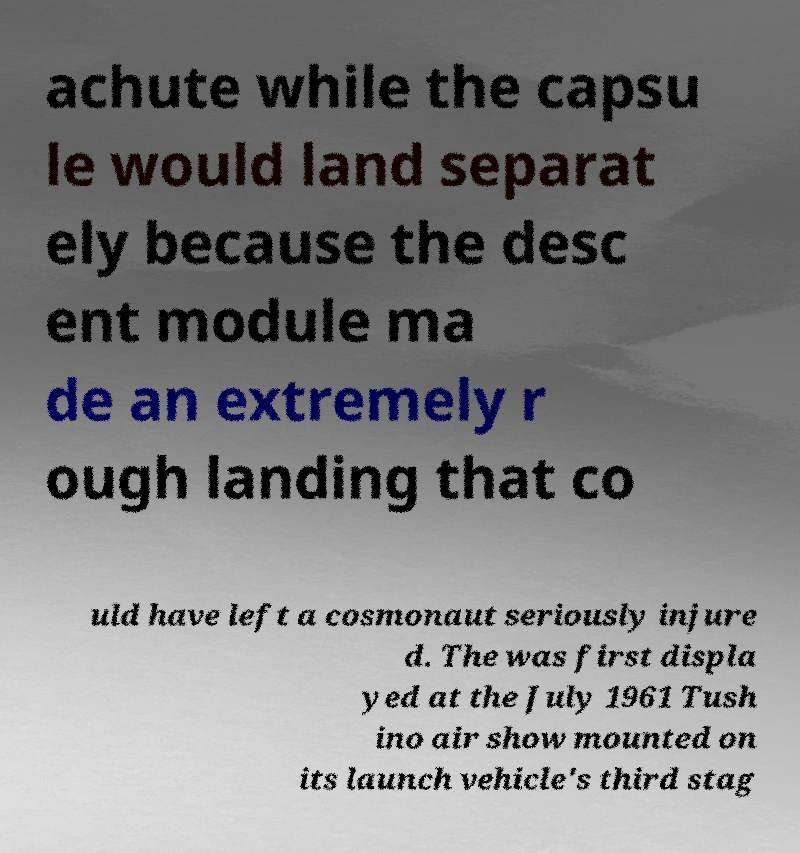I need the written content from this picture converted into text. Can you do that? achute while the capsu le would land separat ely because the desc ent module ma de an extremely r ough landing that co uld have left a cosmonaut seriously injure d. The was first displa yed at the July 1961 Tush ino air show mounted on its launch vehicle's third stag 